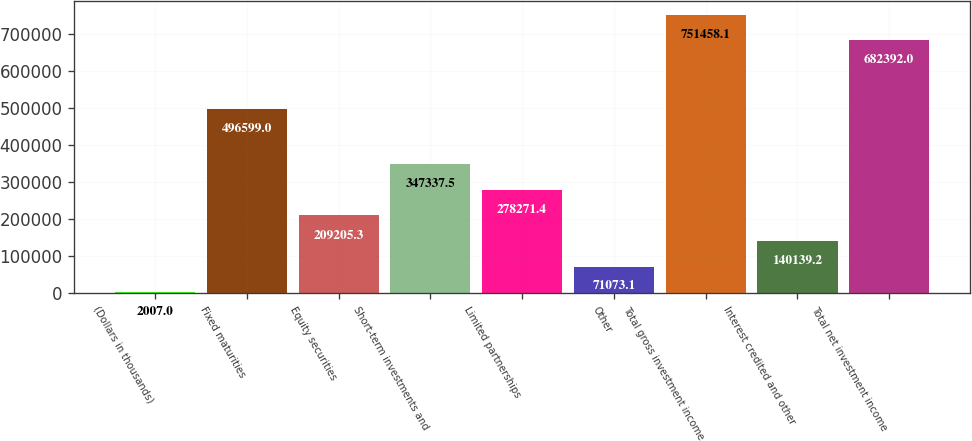Convert chart. <chart><loc_0><loc_0><loc_500><loc_500><bar_chart><fcel>(Dollars in thousands)<fcel>Fixed maturities<fcel>Equity securities<fcel>Short-term investments and<fcel>Limited partnerships<fcel>Other<fcel>Total gross investment income<fcel>Interest credited and other<fcel>Total net investment income<nl><fcel>2007<fcel>496599<fcel>209205<fcel>347338<fcel>278271<fcel>71073.1<fcel>751458<fcel>140139<fcel>682392<nl></chart> 